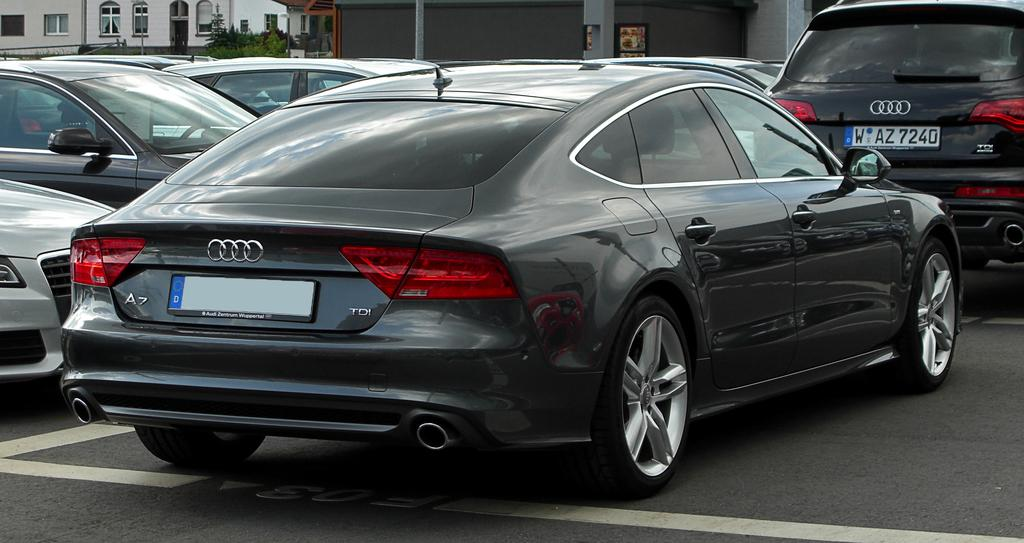<image>
Offer a succinct explanation of the picture presented. An Audi with a blank tag on it in front of another Audi. 